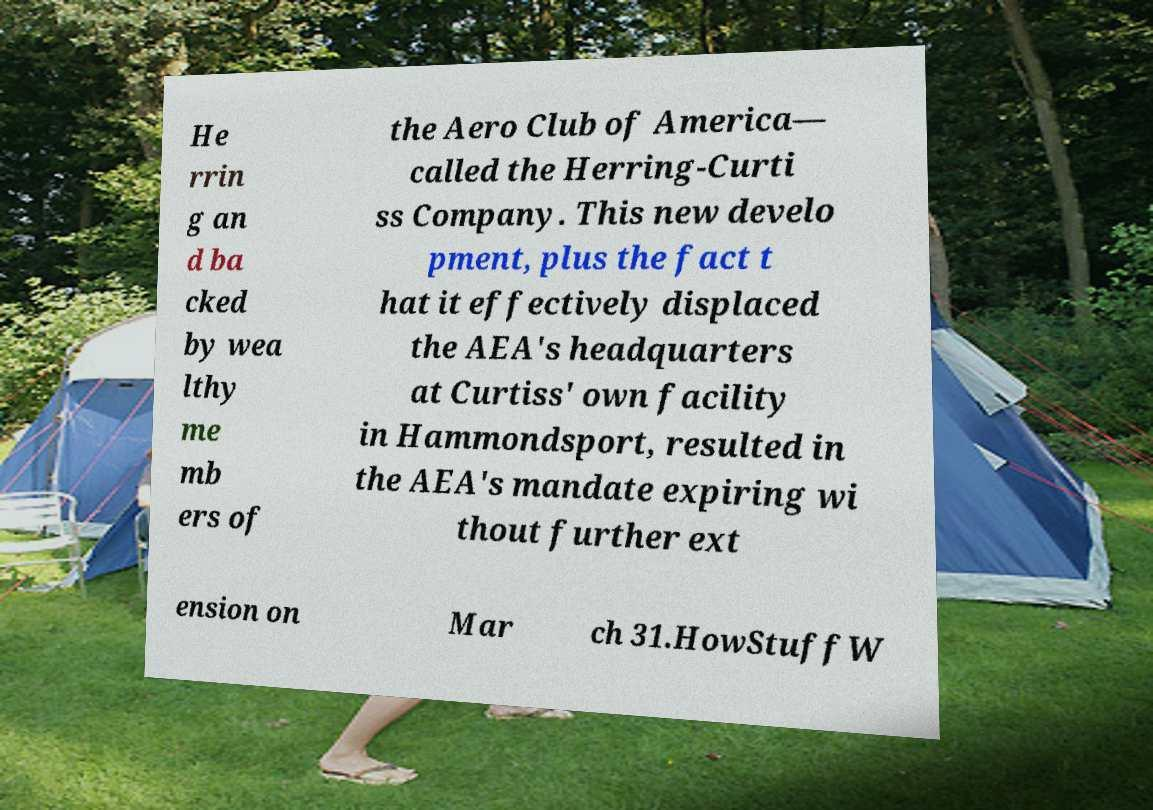Could you extract and type out the text from this image? He rrin g an d ba cked by wea lthy me mb ers of the Aero Club of America— called the Herring-Curti ss Company. This new develo pment, plus the fact t hat it effectively displaced the AEA's headquarters at Curtiss' own facility in Hammondsport, resulted in the AEA's mandate expiring wi thout further ext ension on Mar ch 31.HowStuffW 